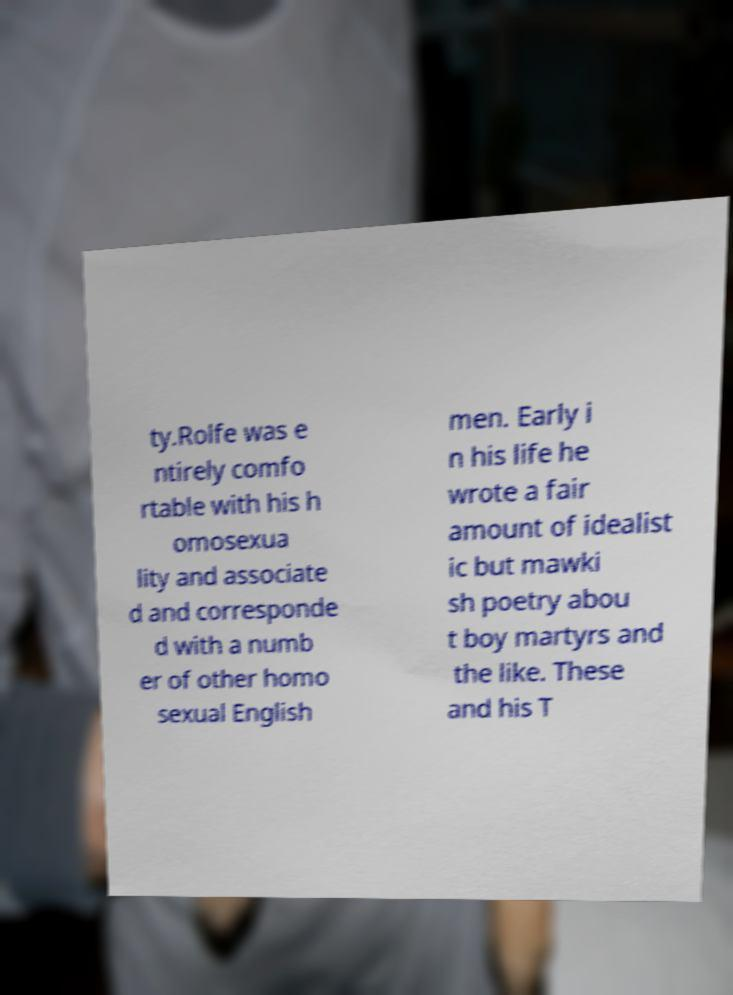Please identify and transcribe the text found in this image. ty.Rolfe was e ntirely comfo rtable with his h omosexua lity and associate d and corresponde d with a numb er of other homo sexual English men. Early i n his life he wrote a fair amount of idealist ic but mawki sh poetry abou t boy martyrs and the like. These and his T 